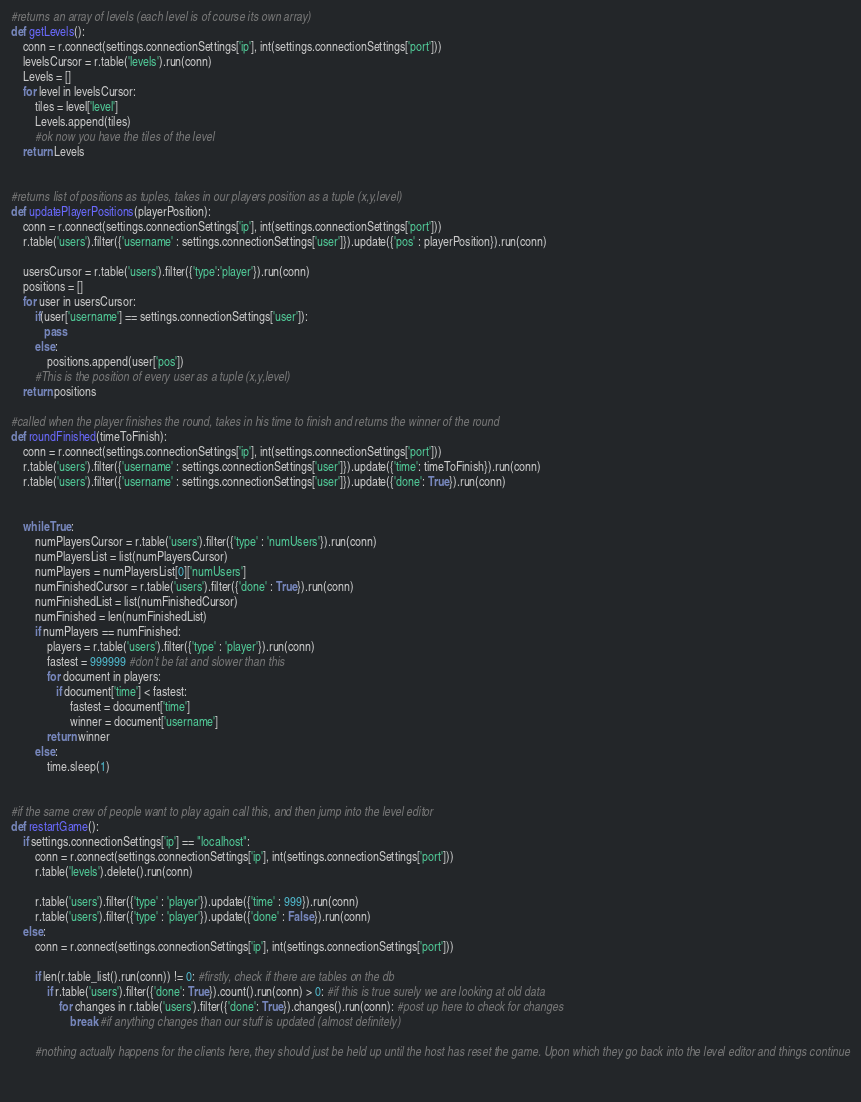<code> <loc_0><loc_0><loc_500><loc_500><_Python_>#returns an array of levels (each level is of course its own array)
def getLevels():
    conn = r.connect(settings.connectionSettings['ip'], int(settings.connectionSettings['port']))
    levelsCursor = r.table('levels').run(conn)
    Levels = []
    for level in levelsCursor:
        tiles = level['level']
        Levels.append(tiles)
        #ok now you have the tiles of the level
    return Levels


#returns list of positions as tuples, takes in our players position as a tuple (x,y,level)
def updatePlayerPositions(playerPosition):
    conn = r.connect(settings.connectionSettings['ip'], int(settings.connectionSettings['port']))
    r.table('users').filter({'username' : settings.connectionSettings['user']}).update({'pos' : playerPosition}).run(conn)

    usersCursor = r.table('users').filter({'type':'player'}).run(conn)
    positions = []
    for user in usersCursor:
        if(user['username'] == settings.connectionSettings['user']):
           pass
        else:
            positions.append(user['pos'])
        #This is the position of every user as a tuple (x,y,level)
    return positions

#called when the player finishes the round, takes in his time to finish and returns the winner of the round
def roundFinished(timeToFinish):
    conn = r.connect(settings.connectionSettings['ip'], int(settings.connectionSettings['port']))
    r.table('users').filter({'username' : settings.connectionSettings['user']}).update({'time': timeToFinish}).run(conn)
    r.table('users').filter({'username' : settings.connectionSettings['user']}).update({'done': True}).run(conn)


    while True:
        numPlayersCursor = r.table('users').filter({'type' : 'numUsers'}).run(conn)
        numPlayersList = list(numPlayersCursor)
        numPlayers = numPlayersList[0]['numUsers']
        numFinishedCursor = r.table('users').filter({'done' : True}).run(conn)
        numFinishedList = list(numFinishedCursor)
        numFinished = len(numFinishedList)
        if numPlayers == numFinished:
            players = r.table('users').filter({'type' : 'player'}).run(conn)
            fastest = 999999 #don't be fat and slower than this
            for document in players:
               if document['time'] < fastest:
                    fastest = document['time']
                    winner = document['username']
            return winner
        else:
            time.sleep(1)


#if the same crew of people want to play again call this, and then jump into the level editor
def restartGame():
    if settings.connectionSettings['ip'] == "localhost":
        conn = r.connect(settings.connectionSettings['ip'], int(settings.connectionSettings['port']))
        r.table('levels').delete().run(conn)

        r.table('users').filter({'type' : 'player'}).update({'time' : 999}).run(conn)
        r.table('users').filter({'type' : 'player'}).update({'done' : False}).run(conn)
    else:
        conn = r.connect(settings.connectionSettings['ip'], int(settings.connectionSettings['port']))

        if len(r.table_list().run(conn)) != 0: #firstly, check if there are tables on the db
            if r.table('users').filter({'done': True}).count().run(conn) > 0: #if this is true surely we are looking at old data
                for changes in r.table('users').filter({'done': True}).changes().run(conn): #post up here to check for changes
                    break #if anything changes than our stuff is updated (almost definitely)

        #nothing actually happens for the clients here, they should just be held up until the host has reset the game. Upon which they go back into the level editor and things continue

            
</code> 